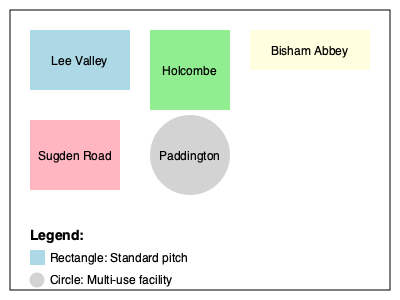Which of the depicted British field hockey stadiums has a unique circular layout, indicating its multi-use nature? To answer this question, we need to analyze the layouts of the various British field hockey stadiums shown in the diagram:

1. Lee Valley Hockey and Tennis Centre: Represented by a rectangular shape in light blue.
2. Holcombe Hockey Club: Shown as a square shape in light green.
3. Bisham Abbey National Sports Centre: Depicted as a rectangular shape in light yellow.
4. Sugden Road: Illustrated as a rectangular shape in light pink.
5. Paddington Recreation Ground: Uniquely represented by a circular shape in light grey.

The legend at the bottom of the diagram indicates that rectangular shapes represent standard pitches, while a circular shape represents a multi-use facility.

Upon examination, we can see that only one stadium is depicted with a circular layout: Paddington Recreation Ground. This unique circular representation, according to the legend, signifies that it is a multi-use facility, setting it apart from the other standard pitch layouts.
Answer: Paddington Recreation Ground 